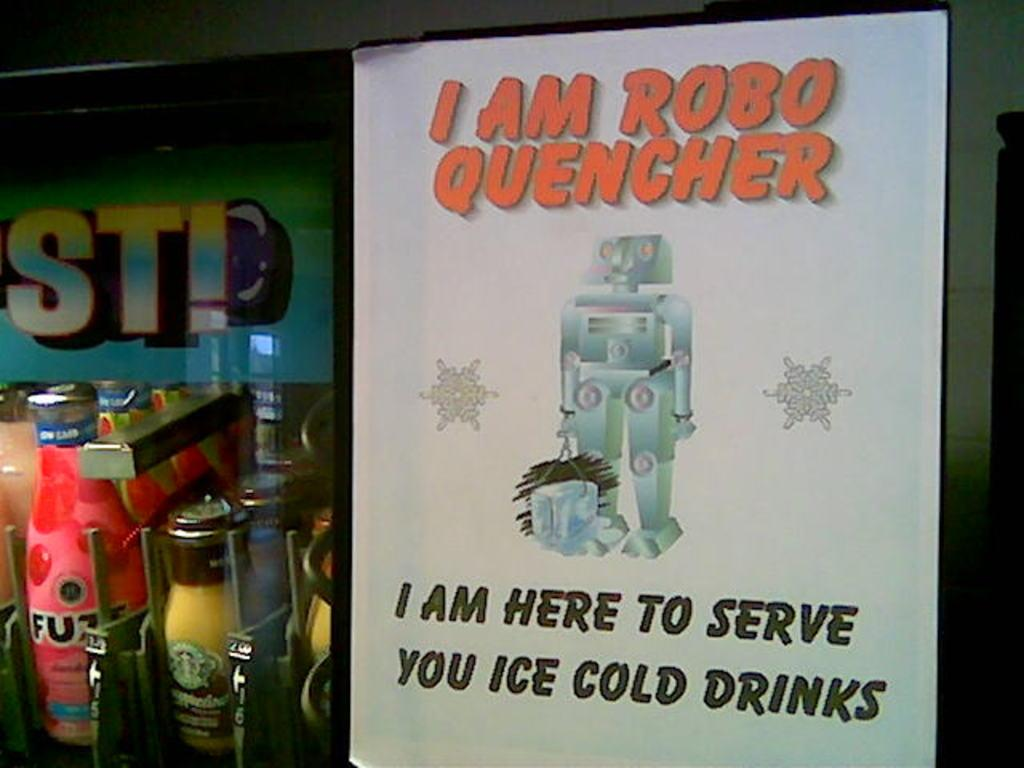<image>
Write a terse but informative summary of the picture. A machine called Robo Quencher that serves you bottles of ice cold drinks. 